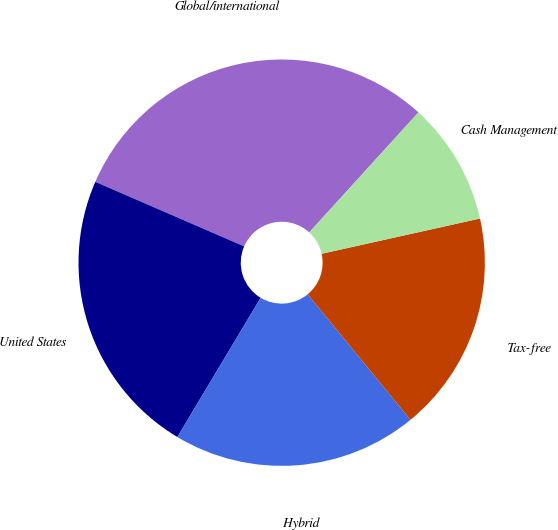Convert chart. <chart><loc_0><loc_0><loc_500><loc_500><pie_chart><fcel>Global/international<fcel>United States<fcel>Hybrid<fcel>Tax-free<fcel>Cash Management<nl><fcel>30.24%<fcel>22.93%<fcel>19.51%<fcel>17.56%<fcel>9.76%<nl></chart> 